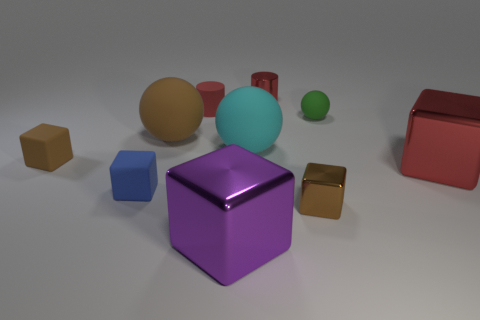Subtract all cyan cubes. Subtract all purple cylinders. How many cubes are left? 5 Subtract all balls. How many objects are left? 7 Subtract all brown matte spheres. Subtract all small brown cubes. How many objects are left? 7 Add 9 big purple metal objects. How many big purple metal objects are left? 10 Add 7 tiny yellow things. How many tiny yellow things exist? 7 Subtract 1 cyan spheres. How many objects are left? 9 